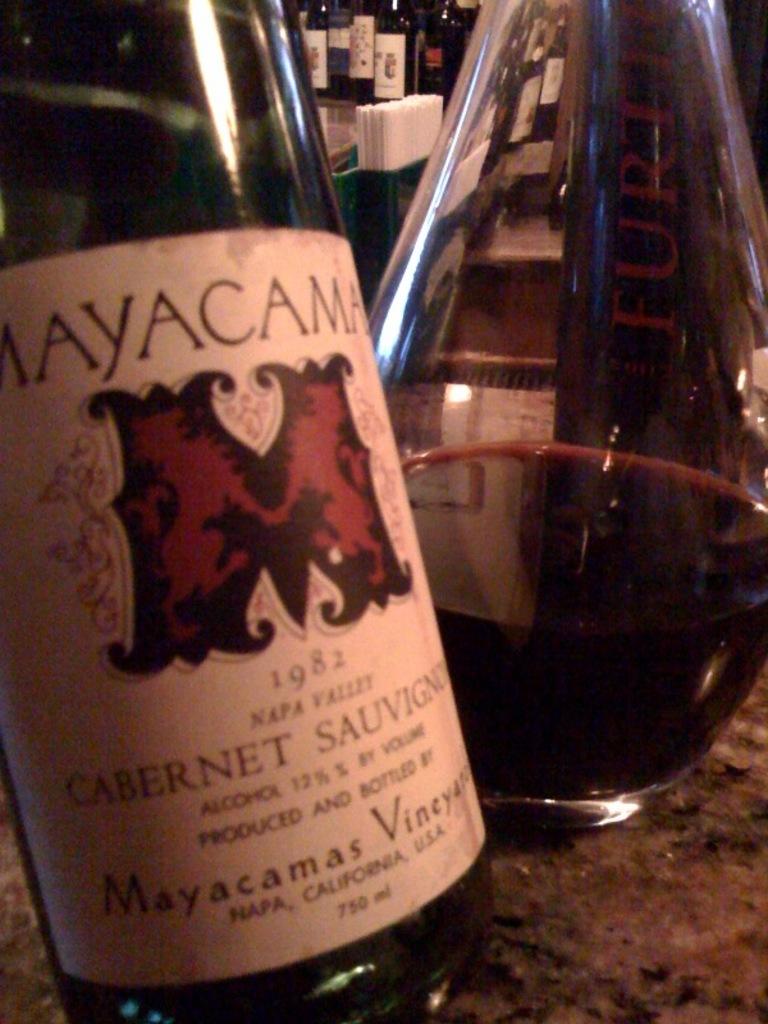What date is on this bottle?
Your answer should be very brief. 1982. What us state is on the bottle?
Give a very brief answer. California. 